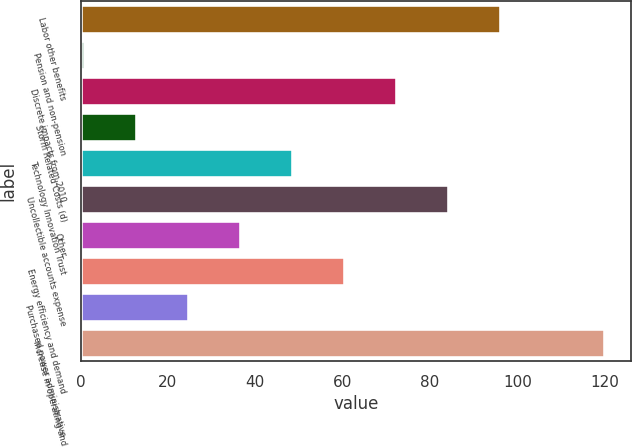Convert chart. <chart><loc_0><loc_0><loc_500><loc_500><bar_chart><fcel>Labor other benefits<fcel>Pension and non-pension<fcel>Discrete impacts from 2010<fcel>Storm Related Costs (d)<fcel>Technology Innovation Trust<fcel>Uncollectible accounts expense<fcel>Other<fcel>Energy efficiency and demand<fcel>Purchased power administrative<fcel>Increase in operating and<nl><fcel>96.2<fcel>1<fcel>72.4<fcel>12.9<fcel>48.6<fcel>84.3<fcel>36.7<fcel>60.5<fcel>24.8<fcel>120<nl></chart> 